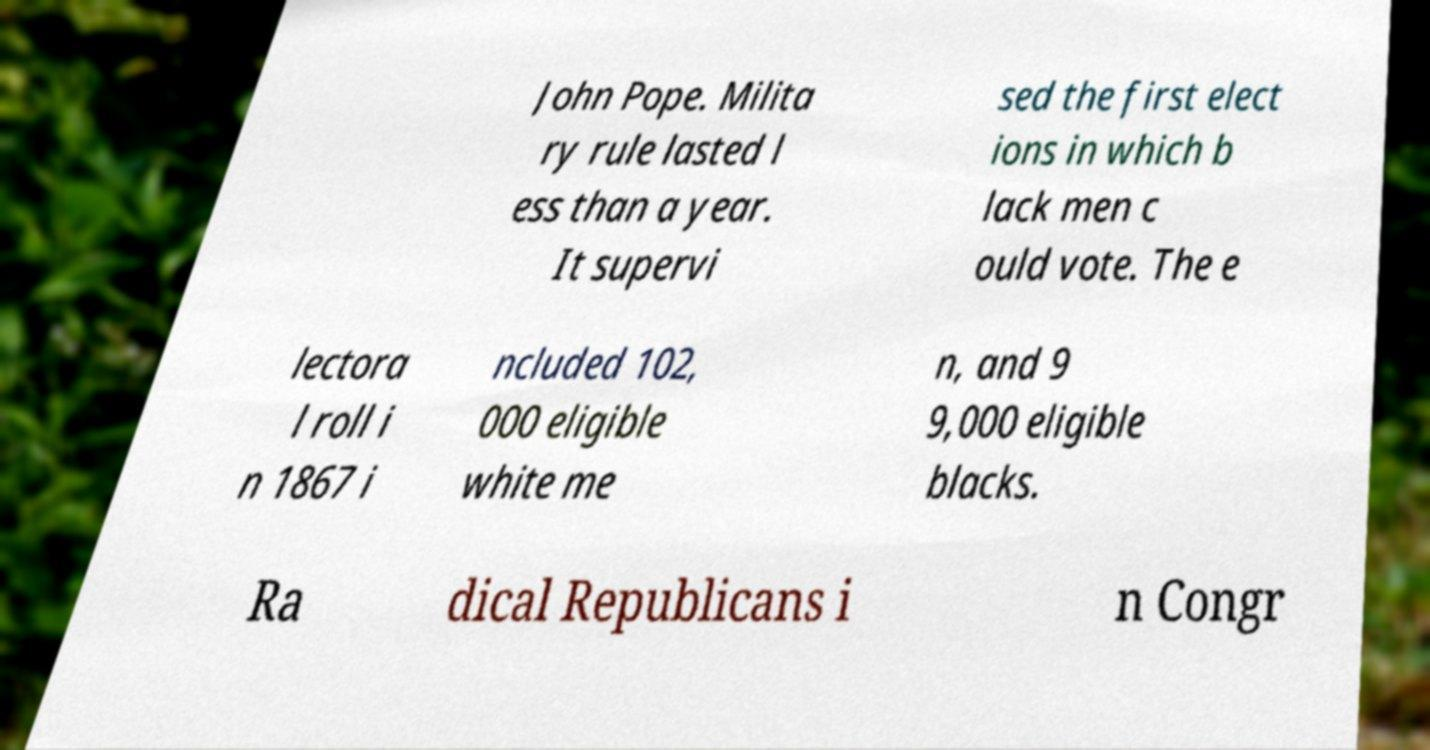Can you accurately transcribe the text from the provided image for me? John Pope. Milita ry rule lasted l ess than a year. It supervi sed the first elect ions in which b lack men c ould vote. The e lectora l roll i n 1867 i ncluded 102, 000 eligible white me n, and 9 9,000 eligible blacks. Ra dical Republicans i n Congr 